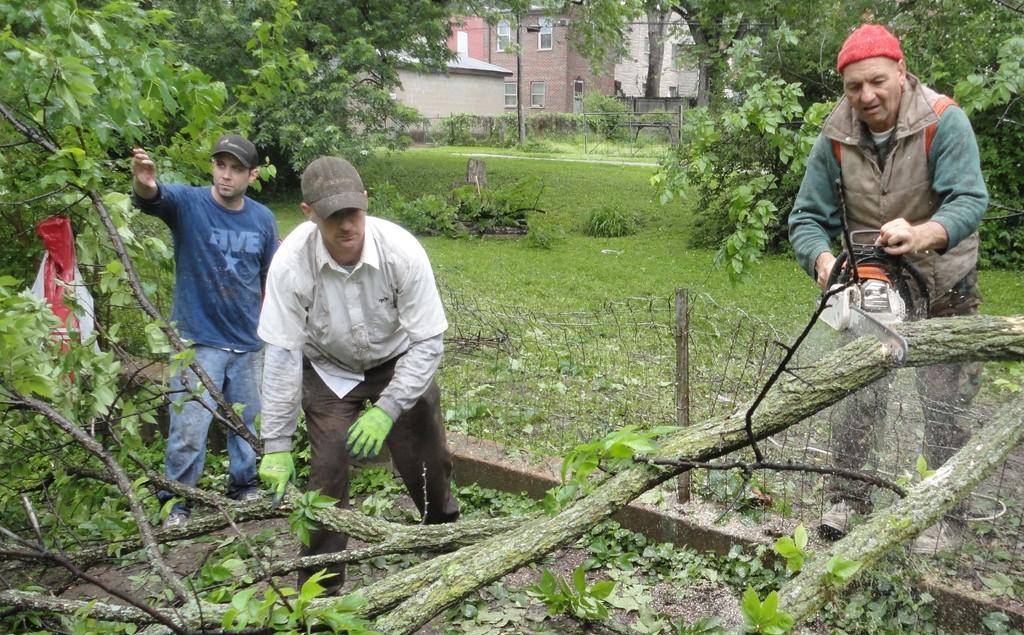In one or two sentences, can you explain what this image depicts? In this picture, we can see a few people holding some objects and we can see the ground covered with grass, trees and we can see some objects on the ground, we can see some buildings with windows, poles, lights and fencing. 